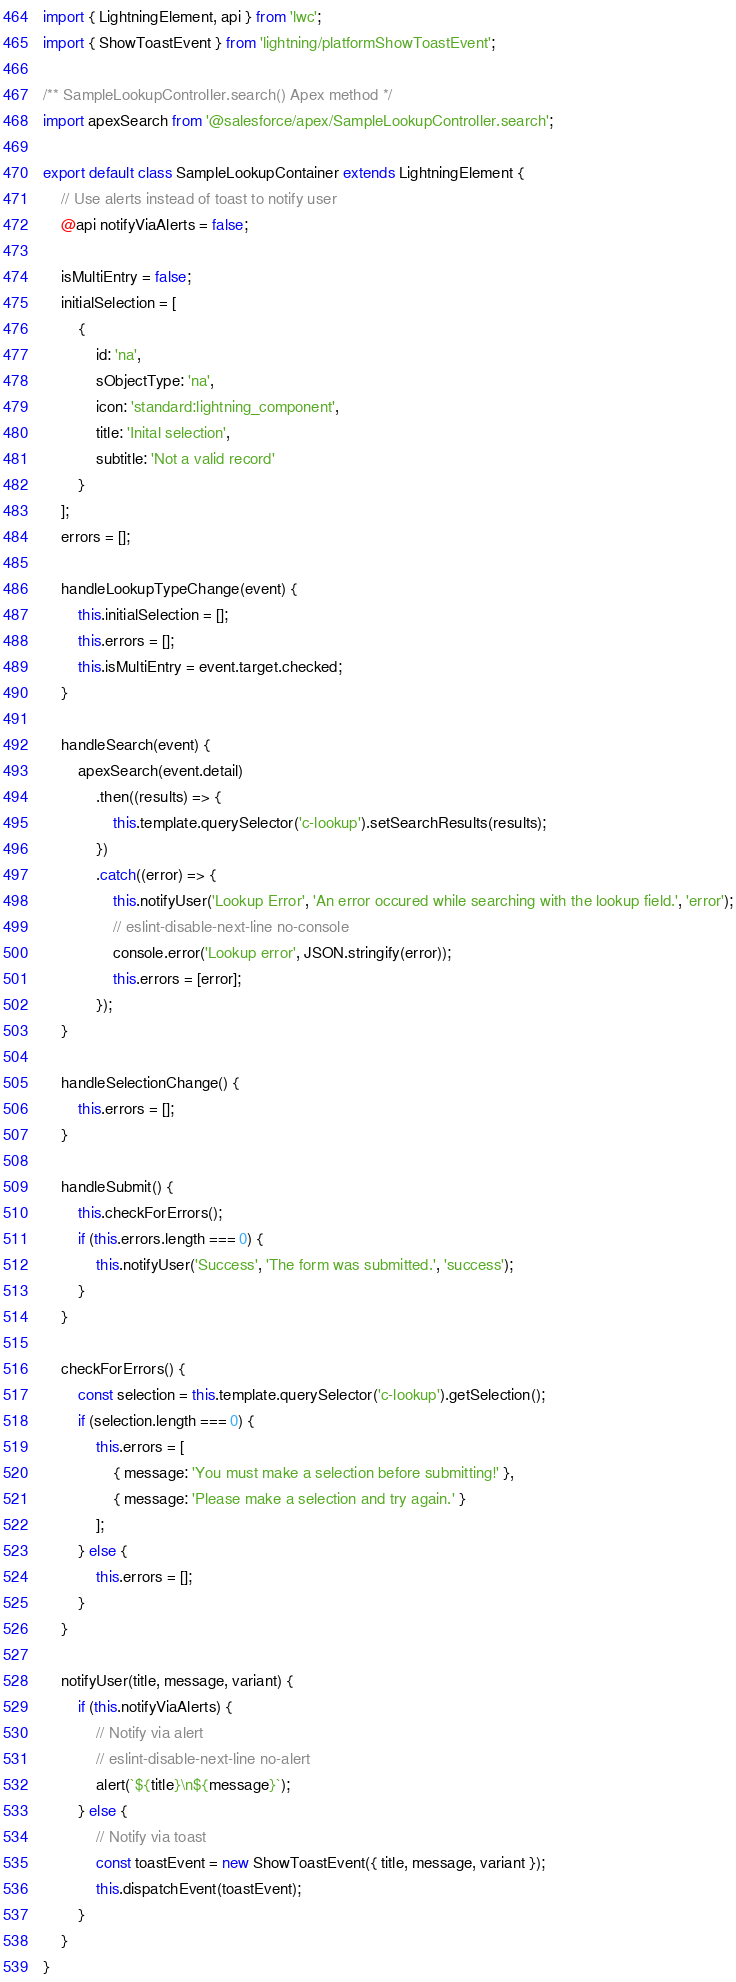Convert code to text. <code><loc_0><loc_0><loc_500><loc_500><_JavaScript_>import { LightningElement, api } from 'lwc';
import { ShowToastEvent } from 'lightning/platformShowToastEvent';

/** SampleLookupController.search() Apex method */
import apexSearch from '@salesforce/apex/SampleLookupController.search';

export default class SampleLookupContainer extends LightningElement {
    // Use alerts instead of toast to notify user
    @api notifyViaAlerts = false;

    isMultiEntry = false;
    initialSelection = [
        {
            id: 'na',
            sObjectType: 'na',
            icon: 'standard:lightning_component',
            title: 'Inital selection',
            subtitle: 'Not a valid record'
        }
    ];
    errors = [];

    handleLookupTypeChange(event) {
        this.initialSelection = [];
        this.errors = [];
        this.isMultiEntry = event.target.checked;
    }

    handleSearch(event) {
        apexSearch(event.detail)
            .then((results) => {
                this.template.querySelector('c-lookup').setSearchResults(results);
            })
            .catch((error) => {
                this.notifyUser('Lookup Error', 'An error occured while searching with the lookup field.', 'error');
                // eslint-disable-next-line no-console
                console.error('Lookup error', JSON.stringify(error));
                this.errors = [error];
            });
    }

    handleSelectionChange() {
        this.errors = [];
    }

    handleSubmit() {
        this.checkForErrors();
        if (this.errors.length === 0) {
            this.notifyUser('Success', 'The form was submitted.', 'success');
        }
    }

    checkForErrors() {
        const selection = this.template.querySelector('c-lookup').getSelection();
        if (selection.length === 0) {
            this.errors = [
                { message: 'You must make a selection before submitting!' },
                { message: 'Please make a selection and try again.' }
            ];
        } else {
            this.errors = [];
        }
    }

    notifyUser(title, message, variant) {
        if (this.notifyViaAlerts) {
            // Notify via alert
            // eslint-disable-next-line no-alert
            alert(`${title}\n${message}`);
        } else {
            // Notify via toast
            const toastEvent = new ShowToastEvent({ title, message, variant });
            this.dispatchEvent(toastEvent);
        }
    }
}
</code> 